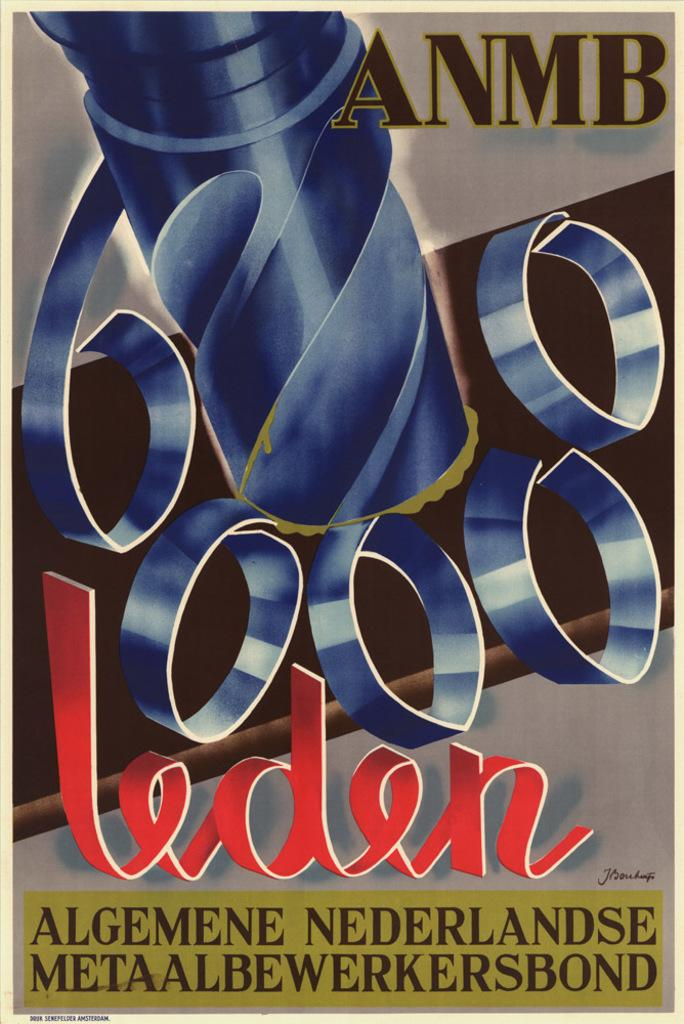<image>
Describe the image concisely. a poster with the word leden on it 